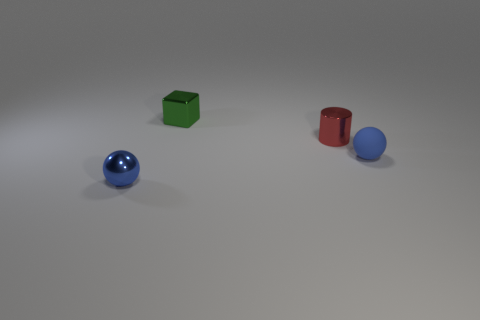Add 3 small metal cylinders. How many objects exist? 7 Subtract all cylinders. How many objects are left? 3 Subtract all tiny blue metal things. Subtract all small metallic cubes. How many objects are left? 2 Add 3 red metallic objects. How many red metallic objects are left? 4 Add 3 metallic things. How many metallic things exist? 6 Subtract 0 red balls. How many objects are left? 4 